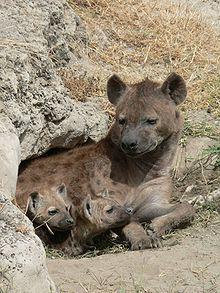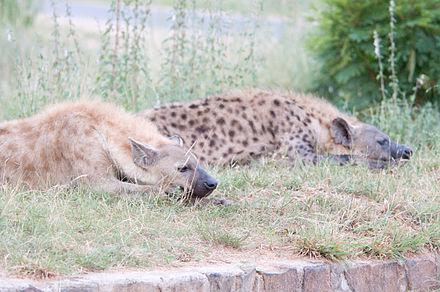The first image is the image on the left, the second image is the image on the right. Given the left and right images, does the statement "The left image contains one hyena laying on its back." hold true? Answer yes or no. No. The first image is the image on the left, the second image is the image on the right. Given the left and right images, does the statement "The combined images include a scene with a hyena at the edge of water and include a hyena lying on its back." hold true? Answer yes or no. No. 